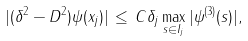<formula> <loc_0><loc_0><loc_500><loc_500>| ( \delta ^ { 2 } - D ^ { 2 } ) \psi ( x _ { j } ) | \, \leq \, C \delta _ { j } \max _ { s \in I _ { j } } | \psi ^ { ( 3 ) } ( s ) | ,</formula> 